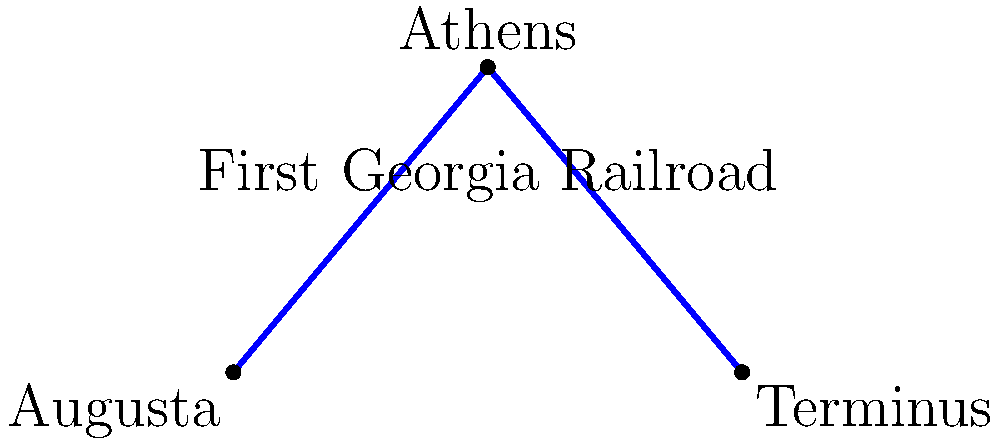On this simplified map of Georgia's first railroad, which city was originally known as "Terminus" and later became a major transportation hub? To answer this question, let's follow these steps:

1. Examine the map provided, which shows the route of Georgia's first railroad.
2. Identify the three cities marked on the map: Augusta, Athens, and Terminus.
3. Recall that "Terminus" was often used as a name for the end point of a railroad line.
4. Consider the historical context: many cities that were railroad endpoints grew into major transportation hubs.
5. Research or recall that Atlanta, now Georgia's capital and largest city, was originally called "Terminus" because it was the end of the Western and Atlantic Railroad line.
6. Match this information with the city labeled "Terminus" on the map.

Therefore, the city originally known as "Terminus" that later became a major transportation hub is modern-day Atlanta.
Answer: Atlanta 